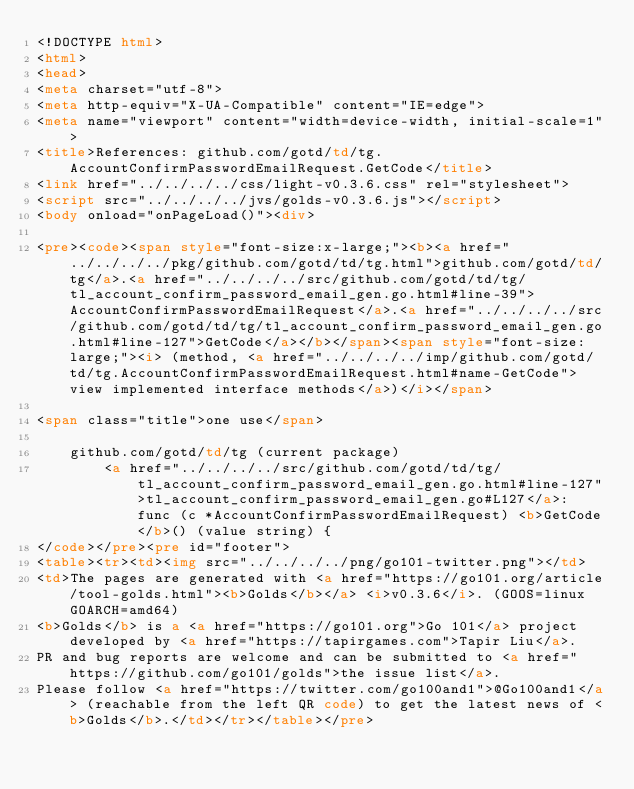Convert code to text. <code><loc_0><loc_0><loc_500><loc_500><_HTML_><!DOCTYPE html>
<html>
<head>
<meta charset="utf-8">
<meta http-equiv="X-UA-Compatible" content="IE=edge">
<meta name="viewport" content="width=device-width, initial-scale=1">
<title>References: github.com/gotd/td/tg.AccountConfirmPasswordEmailRequest.GetCode</title>
<link href="../../../../css/light-v0.3.6.css" rel="stylesheet">
<script src="../../../../jvs/golds-v0.3.6.js"></script>
<body onload="onPageLoad()"><div>

<pre><code><span style="font-size:x-large;"><b><a href="../../../../pkg/github.com/gotd/td/tg.html">github.com/gotd/td/tg</a>.<a href="../../../../src/github.com/gotd/td/tg/tl_account_confirm_password_email_gen.go.html#line-39">AccountConfirmPasswordEmailRequest</a>.<a href="../../../../src/github.com/gotd/td/tg/tl_account_confirm_password_email_gen.go.html#line-127">GetCode</a></b></span><span style="font-size: large;"><i> (method, <a href="../../../../imp/github.com/gotd/td/tg.AccountConfirmPasswordEmailRequest.html#name-GetCode">view implemented interface methods</a>)</i></span>

<span class="title">one use</span>

	github.com/gotd/td/tg (current package)
		<a href="../../../../src/github.com/gotd/td/tg/tl_account_confirm_password_email_gen.go.html#line-127">tl_account_confirm_password_email_gen.go#L127</a>: func (c *AccountConfirmPasswordEmailRequest) <b>GetCode</b>() (value string) {
</code></pre><pre id="footer">
<table><tr><td><img src="../../../../png/go101-twitter.png"></td>
<td>The pages are generated with <a href="https://go101.org/article/tool-golds.html"><b>Golds</b></a> <i>v0.3.6</i>. (GOOS=linux GOARCH=amd64)
<b>Golds</b> is a <a href="https://go101.org">Go 101</a> project developed by <a href="https://tapirgames.com">Tapir Liu</a>.
PR and bug reports are welcome and can be submitted to <a href="https://github.com/go101/golds">the issue list</a>.
Please follow <a href="https://twitter.com/go100and1">@Go100and1</a> (reachable from the left QR code) to get the latest news of <b>Golds</b>.</td></tr></table></pre></code> 